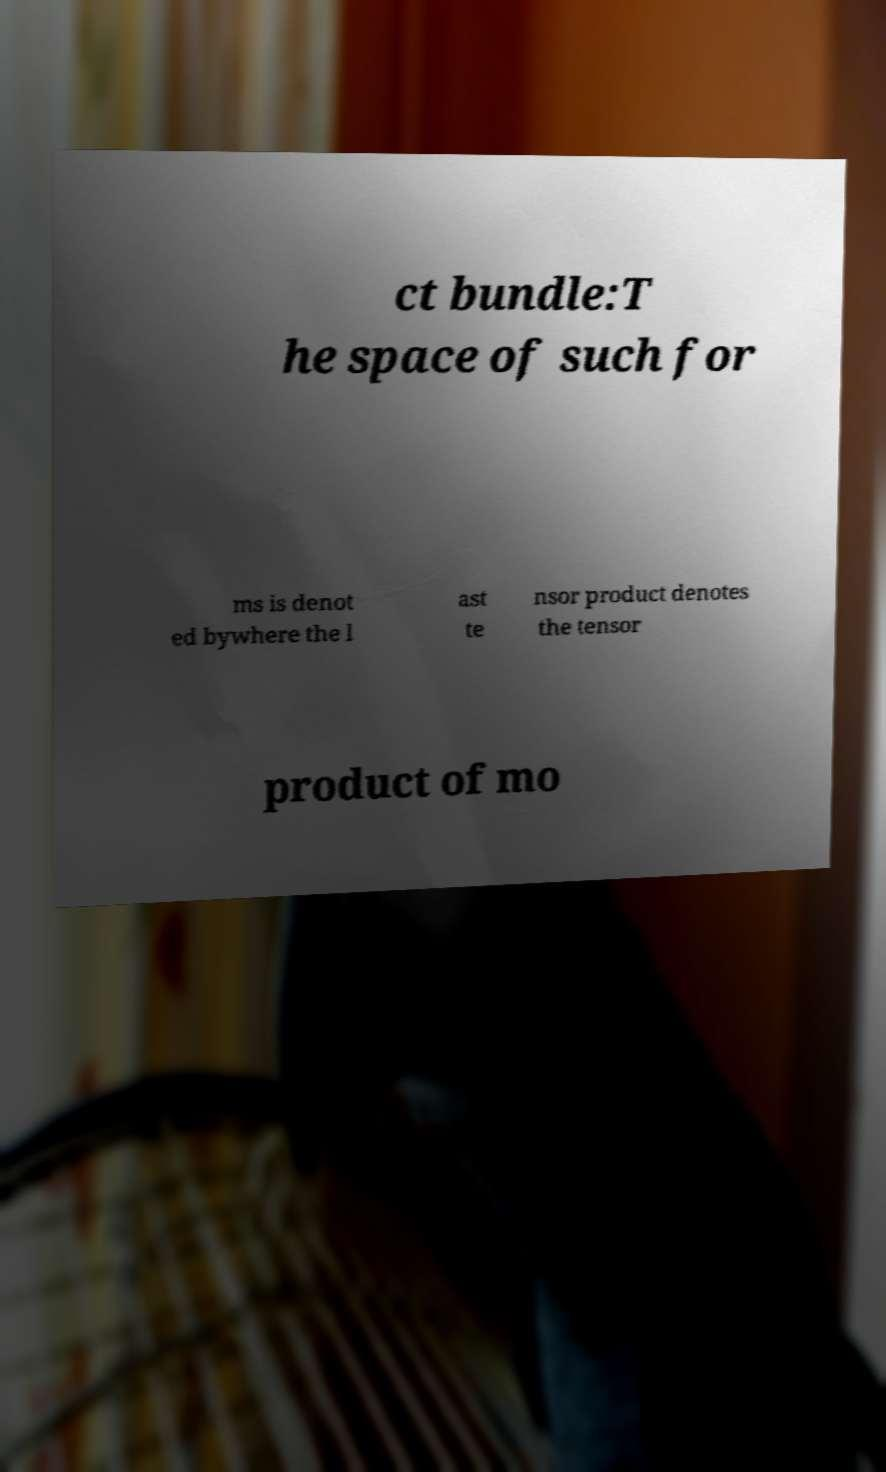Can you accurately transcribe the text from the provided image for me? ct bundle:T he space of such for ms is denot ed bywhere the l ast te nsor product denotes the tensor product of mo 